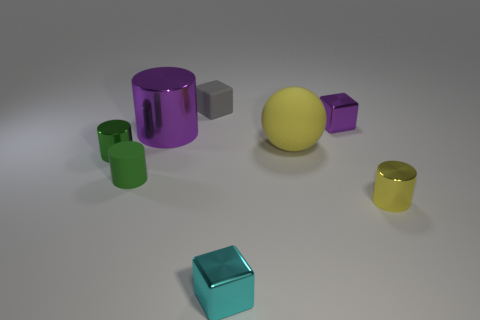Subtract all tiny gray blocks. How many blocks are left? 2 Add 1 large brown shiny things. How many objects exist? 9 Subtract 3 blocks. How many blocks are left? 0 Subtract all gray cubes. How many green cylinders are left? 2 Subtract all green cylinders. How many cylinders are left? 2 Subtract 0 gray cylinders. How many objects are left? 8 Subtract all balls. How many objects are left? 7 Subtract all green cubes. Subtract all green cylinders. How many cubes are left? 3 Subtract all tiny brown metallic cylinders. Subtract all small shiny objects. How many objects are left? 4 Add 7 tiny rubber cylinders. How many tiny rubber cylinders are left? 8 